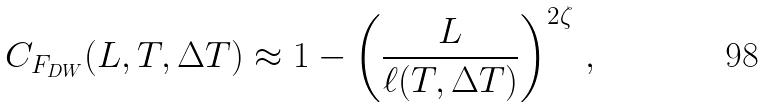<formula> <loc_0><loc_0><loc_500><loc_500>C _ { F _ { D W } } ( L , T , \Delta T ) \approx 1 - \left ( \frac { L } { \ell ( T , \Delta T ) } \right ) ^ { 2 \zeta } \, ,</formula> 